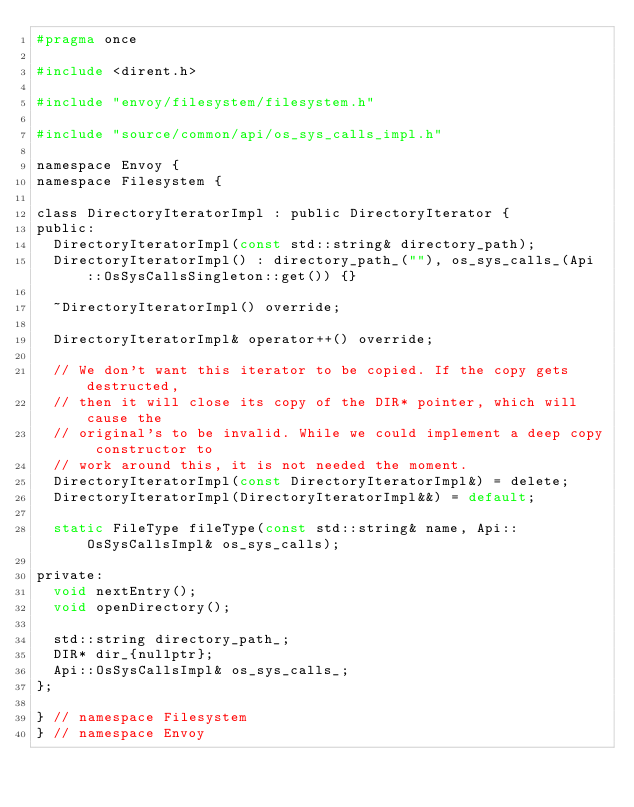Convert code to text. <code><loc_0><loc_0><loc_500><loc_500><_C_>#pragma once

#include <dirent.h>

#include "envoy/filesystem/filesystem.h"

#include "source/common/api/os_sys_calls_impl.h"

namespace Envoy {
namespace Filesystem {

class DirectoryIteratorImpl : public DirectoryIterator {
public:
  DirectoryIteratorImpl(const std::string& directory_path);
  DirectoryIteratorImpl() : directory_path_(""), os_sys_calls_(Api::OsSysCallsSingleton::get()) {}

  ~DirectoryIteratorImpl() override;

  DirectoryIteratorImpl& operator++() override;

  // We don't want this iterator to be copied. If the copy gets destructed,
  // then it will close its copy of the DIR* pointer, which will cause the
  // original's to be invalid. While we could implement a deep copy constructor to
  // work around this, it is not needed the moment.
  DirectoryIteratorImpl(const DirectoryIteratorImpl&) = delete;
  DirectoryIteratorImpl(DirectoryIteratorImpl&&) = default;

  static FileType fileType(const std::string& name, Api::OsSysCallsImpl& os_sys_calls);

private:
  void nextEntry();
  void openDirectory();

  std::string directory_path_;
  DIR* dir_{nullptr};
  Api::OsSysCallsImpl& os_sys_calls_;
};

} // namespace Filesystem
} // namespace Envoy
</code> 